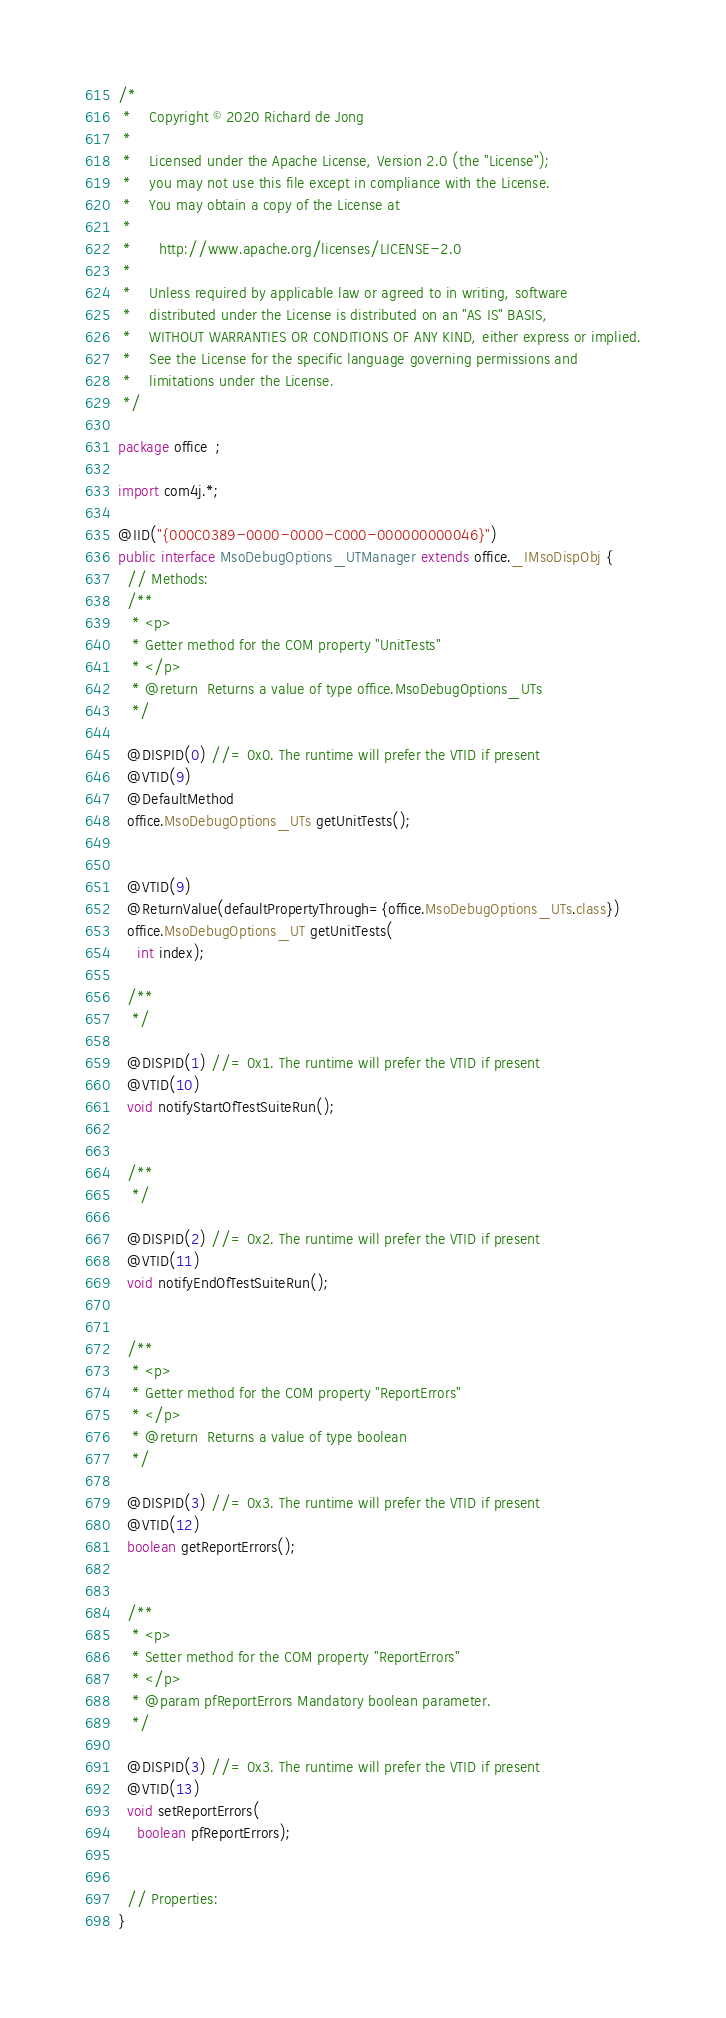Convert code to text. <code><loc_0><loc_0><loc_500><loc_500><_Java_>/*
 *    Copyright © 2020 Richard de Jong
 *
 *    Licensed under the Apache License, Version 2.0 (the "License");
 *    you may not use this file except in compliance with the License.
 *    You may obtain a copy of the License at
 *
 *      http://www.apache.org/licenses/LICENSE-2.0
 *
 *    Unless required by applicable law or agreed to in writing, software
 *    distributed under the License is distributed on an "AS IS" BASIS,
 *    WITHOUT WARRANTIES OR CONDITIONS OF ANY KIND, either express or implied.
 *    See the License for the specific language governing permissions and
 *    limitations under the License.
 */

package office  ;

import com4j.*;

@IID("{000C0389-0000-0000-C000-000000000046}")
public interface MsoDebugOptions_UTManager extends office._IMsoDispObj {
  // Methods:
  /**
   * <p>
   * Getter method for the COM property "UnitTests"
   * </p>
   * @return  Returns a value of type office.MsoDebugOptions_UTs
   */

  @DISPID(0) //= 0x0. The runtime will prefer the VTID if present
  @VTID(9)
  @DefaultMethod
  office.MsoDebugOptions_UTs getUnitTests();


  @VTID(9)
  @ReturnValue(defaultPropertyThrough={office.MsoDebugOptions_UTs.class})
  office.MsoDebugOptions_UT getUnitTests(
    int index);

  /**
   */

  @DISPID(1) //= 0x1. The runtime will prefer the VTID if present
  @VTID(10)
  void notifyStartOfTestSuiteRun();


  /**
   */

  @DISPID(2) //= 0x2. The runtime will prefer the VTID if present
  @VTID(11)
  void notifyEndOfTestSuiteRun();


  /**
   * <p>
   * Getter method for the COM property "ReportErrors"
   * </p>
   * @return  Returns a value of type boolean
   */

  @DISPID(3) //= 0x3. The runtime will prefer the VTID if present
  @VTID(12)
  boolean getReportErrors();


  /**
   * <p>
   * Setter method for the COM property "ReportErrors"
   * </p>
   * @param pfReportErrors Mandatory boolean parameter.
   */

  @DISPID(3) //= 0x3. The runtime will prefer the VTID if present
  @VTID(13)
  void setReportErrors(
    boolean pfReportErrors);


  // Properties:
}
</code> 